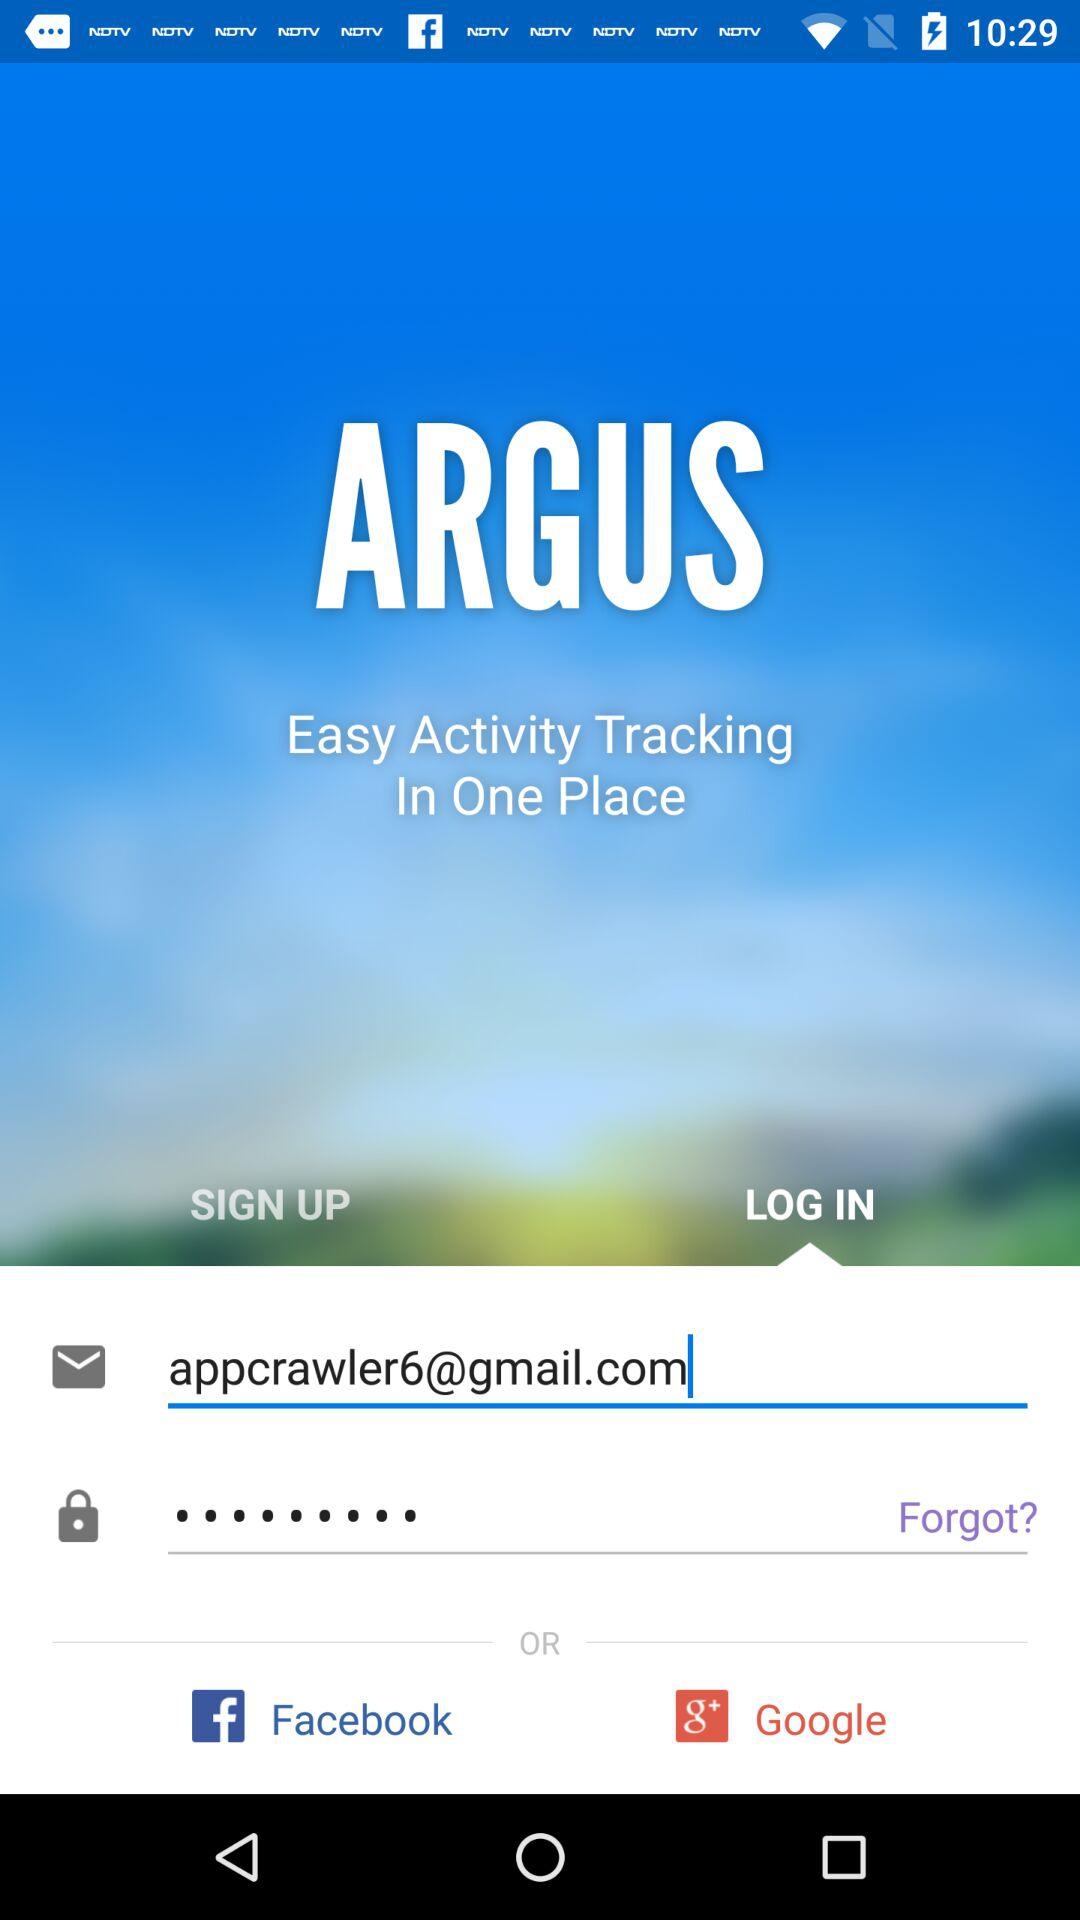How can we log in? You can log in with "Email", "Facebook" and "Google". 